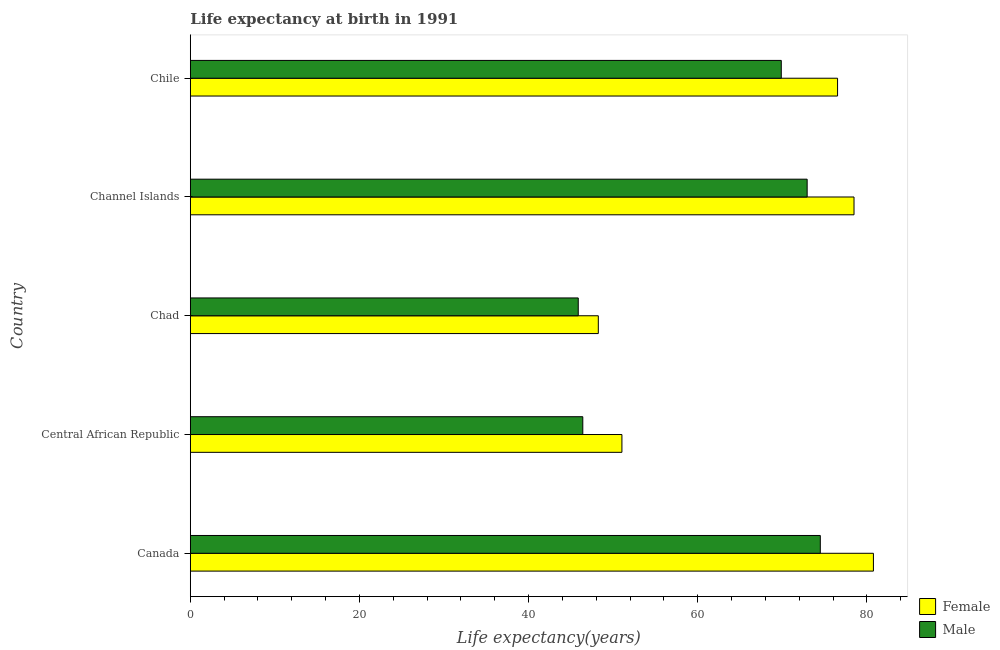How many different coloured bars are there?
Give a very brief answer. 2. How many groups of bars are there?
Provide a succinct answer. 5. Are the number of bars per tick equal to the number of legend labels?
Your answer should be very brief. Yes. What is the label of the 3rd group of bars from the top?
Keep it short and to the point. Chad. What is the life expectancy(male) in Central African Republic?
Offer a very short reply. 46.41. Across all countries, what is the maximum life expectancy(male)?
Provide a succinct answer. 74.49. Across all countries, what is the minimum life expectancy(male)?
Your response must be concise. 45.87. In which country was the life expectancy(male) minimum?
Your response must be concise. Chad. What is the total life expectancy(female) in the graph?
Make the answer very short. 335.05. What is the difference between the life expectancy(female) in Central African Republic and that in Channel Islands?
Your answer should be very brief. -27.44. What is the difference between the life expectancy(female) in Central African Republic and the life expectancy(male) in Chile?
Offer a terse response. -18.84. What is the average life expectancy(female) per country?
Your answer should be very brief. 67.01. What is the difference between the life expectancy(female) and life expectancy(male) in Chad?
Your answer should be compact. 2.37. What is the ratio of the life expectancy(female) in Canada to that in Chile?
Give a very brief answer. 1.05. Is the difference between the life expectancy(female) in Channel Islands and Chile greater than the difference between the life expectancy(male) in Channel Islands and Chile?
Provide a short and direct response. No. What is the difference between the highest and the second highest life expectancy(male)?
Your answer should be compact. 1.56. What is the difference between the highest and the lowest life expectancy(male)?
Offer a very short reply. 28.62. What does the 1st bar from the top in Chile represents?
Provide a short and direct response. Male. What does the 1st bar from the bottom in Central African Republic represents?
Your response must be concise. Female. What is the difference between two consecutive major ticks on the X-axis?
Your response must be concise. 20. Are the values on the major ticks of X-axis written in scientific E-notation?
Give a very brief answer. No. Where does the legend appear in the graph?
Offer a terse response. Bottom right. How many legend labels are there?
Your answer should be compact. 2. What is the title of the graph?
Keep it short and to the point. Life expectancy at birth in 1991. Does "Start a business" appear as one of the legend labels in the graph?
Provide a short and direct response. No. What is the label or title of the X-axis?
Your response must be concise. Life expectancy(years). What is the Life expectancy(years) in Female in Canada?
Provide a succinct answer. 80.77. What is the Life expectancy(years) in Male in Canada?
Your response must be concise. 74.49. What is the Life expectancy(years) of Female in Central African Republic?
Keep it short and to the point. 51.03. What is the Life expectancy(years) of Male in Central African Republic?
Offer a terse response. 46.41. What is the Life expectancy(years) in Female in Chad?
Offer a terse response. 48.24. What is the Life expectancy(years) of Male in Chad?
Offer a terse response. 45.87. What is the Life expectancy(years) in Female in Channel Islands?
Your answer should be very brief. 78.47. What is the Life expectancy(years) of Male in Channel Islands?
Provide a succinct answer. 72.93. What is the Life expectancy(years) in Female in Chile?
Make the answer very short. 76.53. What is the Life expectancy(years) in Male in Chile?
Keep it short and to the point. 69.88. Across all countries, what is the maximum Life expectancy(years) in Female?
Give a very brief answer. 80.77. Across all countries, what is the maximum Life expectancy(years) of Male?
Your response must be concise. 74.49. Across all countries, what is the minimum Life expectancy(years) of Female?
Give a very brief answer. 48.24. Across all countries, what is the minimum Life expectancy(years) in Male?
Provide a short and direct response. 45.87. What is the total Life expectancy(years) of Female in the graph?
Provide a succinct answer. 335.05. What is the total Life expectancy(years) of Male in the graph?
Provide a succinct answer. 309.58. What is the difference between the Life expectancy(years) of Female in Canada and that in Central African Republic?
Offer a terse response. 29.74. What is the difference between the Life expectancy(years) of Male in Canada and that in Central African Republic?
Offer a very short reply. 28.08. What is the difference between the Life expectancy(years) in Female in Canada and that in Chad?
Your answer should be compact. 32.53. What is the difference between the Life expectancy(years) of Male in Canada and that in Chad?
Make the answer very short. 28.62. What is the difference between the Life expectancy(years) of Female in Canada and that in Channel Islands?
Offer a very short reply. 2.29. What is the difference between the Life expectancy(years) in Male in Canada and that in Channel Islands?
Your answer should be compact. 1.56. What is the difference between the Life expectancy(years) of Female in Canada and that in Chile?
Provide a short and direct response. 4.24. What is the difference between the Life expectancy(years) in Male in Canada and that in Chile?
Your answer should be compact. 4.62. What is the difference between the Life expectancy(years) of Female in Central African Republic and that in Chad?
Ensure brevity in your answer.  2.79. What is the difference between the Life expectancy(years) in Male in Central African Republic and that in Chad?
Provide a short and direct response. 0.54. What is the difference between the Life expectancy(years) of Female in Central African Republic and that in Channel Islands?
Provide a succinct answer. -27.44. What is the difference between the Life expectancy(years) of Male in Central African Republic and that in Channel Islands?
Ensure brevity in your answer.  -26.53. What is the difference between the Life expectancy(years) in Female in Central African Republic and that in Chile?
Provide a short and direct response. -25.5. What is the difference between the Life expectancy(years) in Male in Central African Republic and that in Chile?
Offer a terse response. -23.47. What is the difference between the Life expectancy(years) in Female in Chad and that in Channel Islands?
Offer a terse response. -30.23. What is the difference between the Life expectancy(years) of Male in Chad and that in Channel Islands?
Make the answer very short. -27.06. What is the difference between the Life expectancy(years) in Female in Chad and that in Chile?
Make the answer very short. -28.29. What is the difference between the Life expectancy(years) in Male in Chad and that in Chile?
Give a very brief answer. -24. What is the difference between the Life expectancy(years) in Female in Channel Islands and that in Chile?
Keep it short and to the point. 1.95. What is the difference between the Life expectancy(years) of Male in Channel Islands and that in Chile?
Provide a succinct answer. 3.06. What is the difference between the Life expectancy(years) in Female in Canada and the Life expectancy(years) in Male in Central African Republic?
Ensure brevity in your answer.  34.36. What is the difference between the Life expectancy(years) in Female in Canada and the Life expectancy(years) in Male in Chad?
Your answer should be compact. 34.9. What is the difference between the Life expectancy(years) in Female in Canada and the Life expectancy(years) in Male in Channel Islands?
Keep it short and to the point. 7.84. What is the difference between the Life expectancy(years) of Female in Canada and the Life expectancy(years) of Male in Chile?
Offer a terse response. 10.89. What is the difference between the Life expectancy(years) of Female in Central African Republic and the Life expectancy(years) of Male in Chad?
Give a very brief answer. 5.16. What is the difference between the Life expectancy(years) in Female in Central African Republic and the Life expectancy(years) in Male in Channel Islands?
Offer a very short reply. -21.9. What is the difference between the Life expectancy(years) of Female in Central African Republic and the Life expectancy(years) of Male in Chile?
Your answer should be compact. -18.84. What is the difference between the Life expectancy(years) in Female in Chad and the Life expectancy(years) in Male in Channel Islands?
Your response must be concise. -24.69. What is the difference between the Life expectancy(years) of Female in Chad and the Life expectancy(years) of Male in Chile?
Keep it short and to the point. -21.63. What is the average Life expectancy(years) in Female per country?
Make the answer very short. 67.01. What is the average Life expectancy(years) of Male per country?
Your response must be concise. 61.92. What is the difference between the Life expectancy(years) of Female and Life expectancy(years) of Male in Canada?
Provide a succinct answer. 6.28. What is the difference between the Life expectancy(years) in Female and Life expectancy(years) in Male in Central African Republic?
Ensure brevity in your answer.  4.63. What is the difference between the Life expectancy(years) in Female and Life expectancy(years) in Male in Chad?
Your response must be concise. 2.37. What is the difference between the Life expectancy(years) in Female and Life expectancy(years) in Male in Channel Islands?
Your response must be concise. 5.54. What is the difference between the Life expectancy(years) of Female and Life expectancy(years) of Male in Chile?
Give a very brief answer. 6.66. What is the ratio of the Life expectancy(years) of Female in Canada to that in Central African Republic?
Keep it short and to the point. 1.58. What is the ratio of the Life expectancy(years) of Male in Canada to that in Central African Republic?
Your response must be concise. 1.61. What is the ratio of the Life expectancy(years) in Female in Canada to that in Chad?
Offer a terse response. 1.67. What is the ratio of the Life expectancy(years) in Male in Canada to that in Chad?
Give a very brief answer. 1.62. What is the ratio of the Life expectancy(years) of Female in Canada to that in Channel Islands?
Provide a succinct answer. 1.03. What is the ratio of the Life expectancy(years) of Male in Canada to that in Channel Islands?
Your answer should be very brief. 1.02. What is the ratio of the Life expectancy(years) in Female in Canada to that in Chile?
Provide a succinct answer. 1.06. What is the ratio of the Life expectancy(years) in Male in Canada to that in Chile?
Make the answer very short. 1.07. What is the ratio of the Life expectancy(years) in Female in Central African Republic to that in Chad?
Provide a short and direct response. 1.06. What is the ratio of the Life expectancy(years) of Male in Central African Republic to that in Chad?
Make the answer very short. 1.01. What is the ratio of the Life expectancy(years) of Female in Central African Republic to that in Channel Islands?
Give a very brief answer. 0.65. What is the ratio of the Life expectancy(years) in Male in Central African Republic to that in Channel Islands?
Offer a terse response. 0.64. What is the ratio of the Life expectancy(years) of Female in Central African Republic to that in Chile?
Give a very brief answer. 0.67. What is the ratio of the Life expectancy(years) of Male in Central African Republic to that in Chile?
Your response must be concise. 0.66. What is the ratio of the Life expectancy(years) of Female in Chad to that in Channel Islands?
Your answer should be compact. 0.61. What is the ratio of the Life expectancy(years) of Male in Chad to that in Channel Islands?
Your answer should be compact. 0.63. What is the ratio of the Life expectancy(years) of Female in Chad to that in Chile?
Give a very brief answer. 0.63. What is the ratio of the Life expectancy(years) of Male in Chad to that in Chile?
Your answer should be compact. 0.66. What is the ratio of the Life expectancy(years) in Female in Channel Islands to that in Chile?
Your answer should be compact. 1.03. What is the ratio of the Life expectancy(years) of Male in Channel Islands to that in Chile?
Ensure brevity in your answer.  1.04. What is the difference between the highest and the second highest Life expectancy(years) in Female?
Provide a short and direct response. 2.29. What is the difference between the highest and the second highest Life expectancy(years) in Male?
Give a very brief answer. 1.56. What is the difference between the highest and the lowest Life expectancy(years) in Female?
Provide a short and direct response. 32.53. What is the difference between the highest and the lowest Life expectancy(years) of Male?
Offer a very short reply. 28.62. 